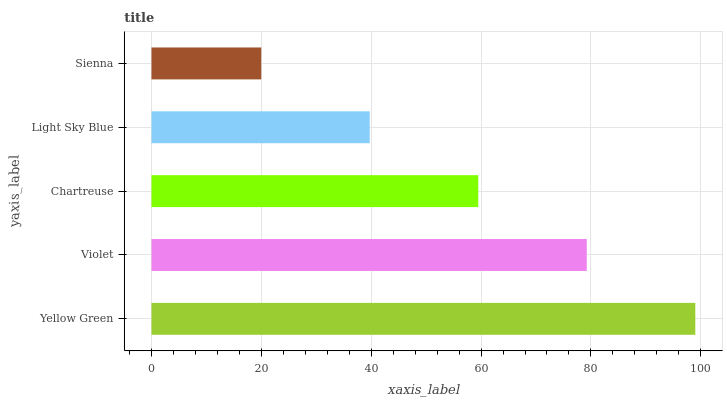Is Sienna the minimum?
Answer yes or no. Yes. Is Yellow Green the maximum?
Answer yes or no. Yes. Is Violet the minimum?
Answer yes or no. No. Is Violet the maximum?
Answer yes or no. No. Is Yellow Green greater than Violet?
Answer yes or no. Yes. Is Violet less than Yellow Green?
Answer yes or no. Yes. Is Violet greater than Yellow Green?
Answer yes or no. No. Is Yellow Green less than Violet?
Answer yes or no. No. Is Chartreuse the high median?
Answer yes or no. Yes. Is Chartreuse the low median?
Answer yes or no. Yes. Is Light Sky Blue the high median?
Answer yes or no. No. Is Light Sky Blue the low median?
Answer yes or no. No. 